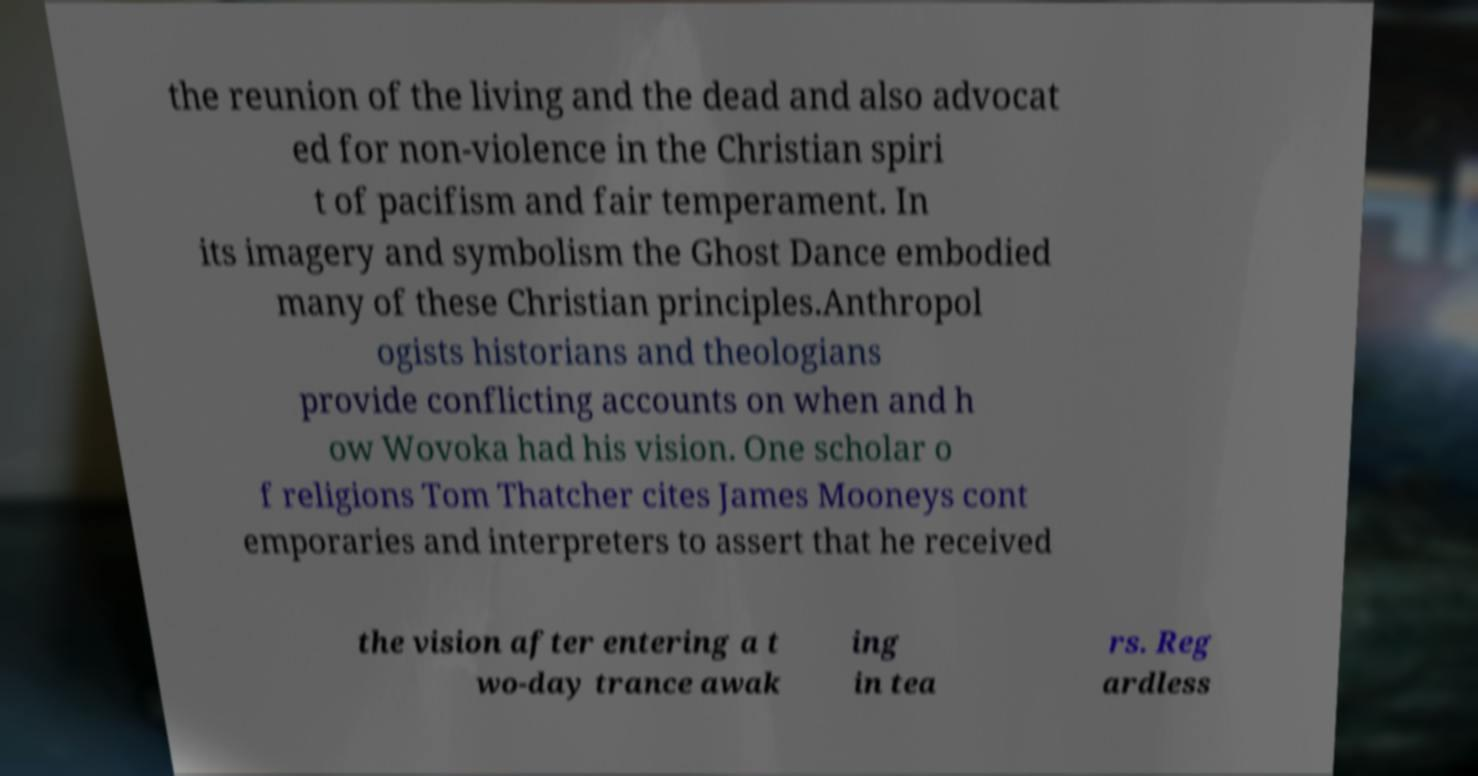There's text embedded in this image that I need extracted. Can you transcribe it verbatim? the reunion of the living and the dead and also advocat ed for non-violence in the Christian spiri t of pacifism and fair temperament. In its imagery and symbolism the Ghost Dance embodied many of these Christian principles.Anthropol ogists historians and theologians provide conflicting accounts on when and h ow Wovoka had his vision. One scholar o f religions Tom Thatcher cites James Mooneys cont emporaries and interpreters to assert that he received the vision after entering a t wo-day trance awak ing in tea rs. Reg ardless 